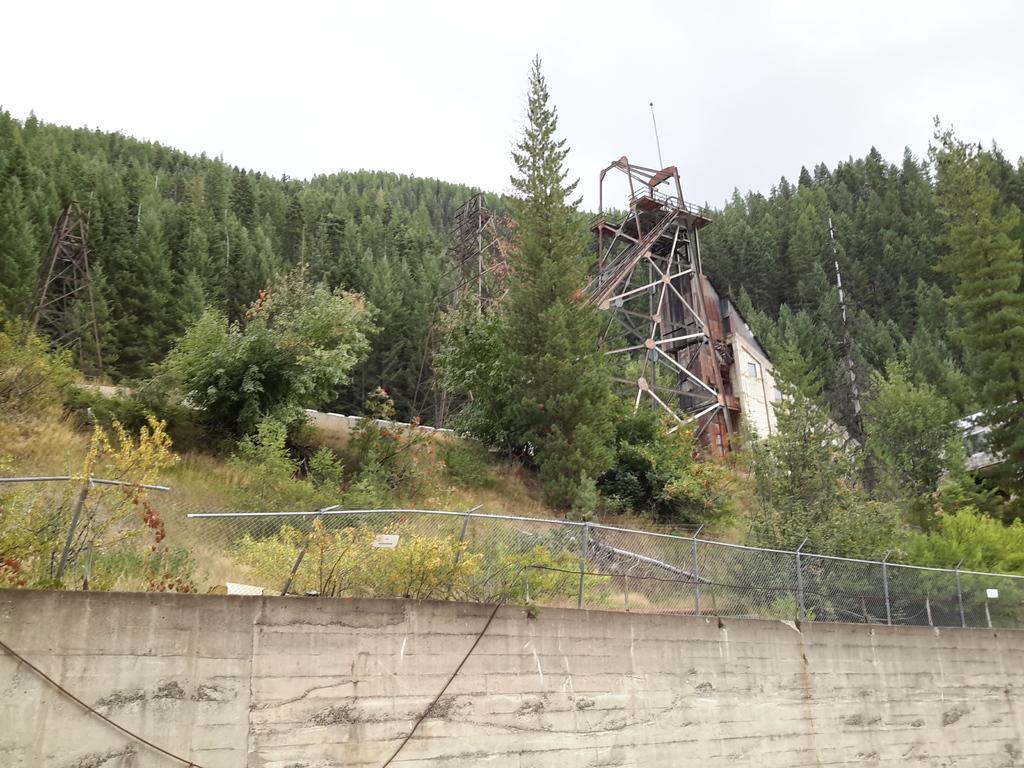Could you give a brief overview of what you see in this image? In the picture we can see a wall with fencing on it and behind it we can see grass, plants, trees and sky. 